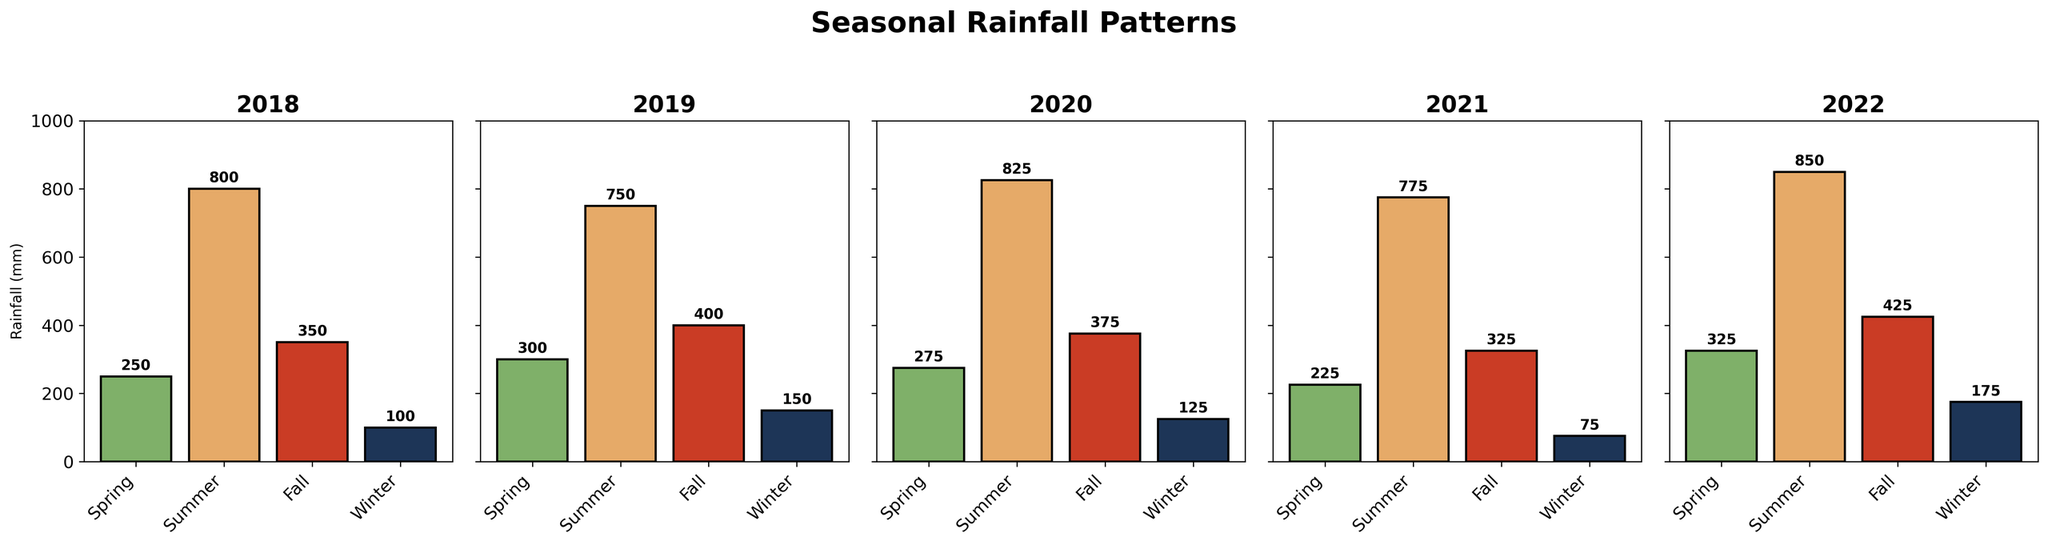Which year had the highest rainfall in Summer? To determine the year with the highest rainfall in Summer, look at the height of the bars labeled 'Summer' across all five subplots. The tallest bar indicates the year.
Answer: 2022 Compare the rainfall in Spring and Fall for the year 2019. Which season had more rainfall? Find the subplot for the year 2019. Compare the heights of the 'Spring' and 'Fall' bars. The taller bar represents the season with more rainfall.
Answer: Fall What is the average rainfall across all seasons for the year 2020? Add the rainfall values for Spring, Summer, Fall, and Winter of 2020: 275 + 825 + 375 + 125. Then, divide the sum by 4.
Answer: 400 mm Which year had the least rainfall in Winter? Look at the height of the bars labeled 'Winter' in all the subplots. The shortest bar represents the year with the least rainfall in Winter.
Answer: 2021 In which year was the rainfall pattern the most evenly distributed across all seasons? Scan through all the subplots and compare the bars within each year. The year where the bars are most similar in height indicates the most evenly distributed rainfall pattern.
Answer: 2020 How much more rainfall did Fall have compared to Winter in the year 2018? Find the 2018 subplot and subtract the Winter rainfall from the Fall rainfall: 350 - 100.
Answer: 250 mm Which two seasons had the closest rainfall amounts in 2021? Look at the subplot for 2021. Compare the heights of the bars across all seasons and find the two seasons with the most similar heights.
Answer: Spring and Fall What is the total rainfall for the year 2022 across all seasons? Add the rainfall values for Spring, Summer, Fall, and Winter of 2022: 325 + 850 + 425 + 175.
Answer: 1775 mm Compare Summer rainfall between 2018 and 2021. How much more or less is it? Subtract the Summer rainfall of 2021 from 2018: 800 - 775.
Answer: 25 mm more Which year had the highest rainfall in both Spring and Fall combined? For each year, add the Spring and Fall rainfalls then compare the combined totals across the years. The year with the highest combined total is the answer. (2018: 600, 2019: 700, 2020: 650, 2021: 550, 2022: 750).
Answer: 2022 